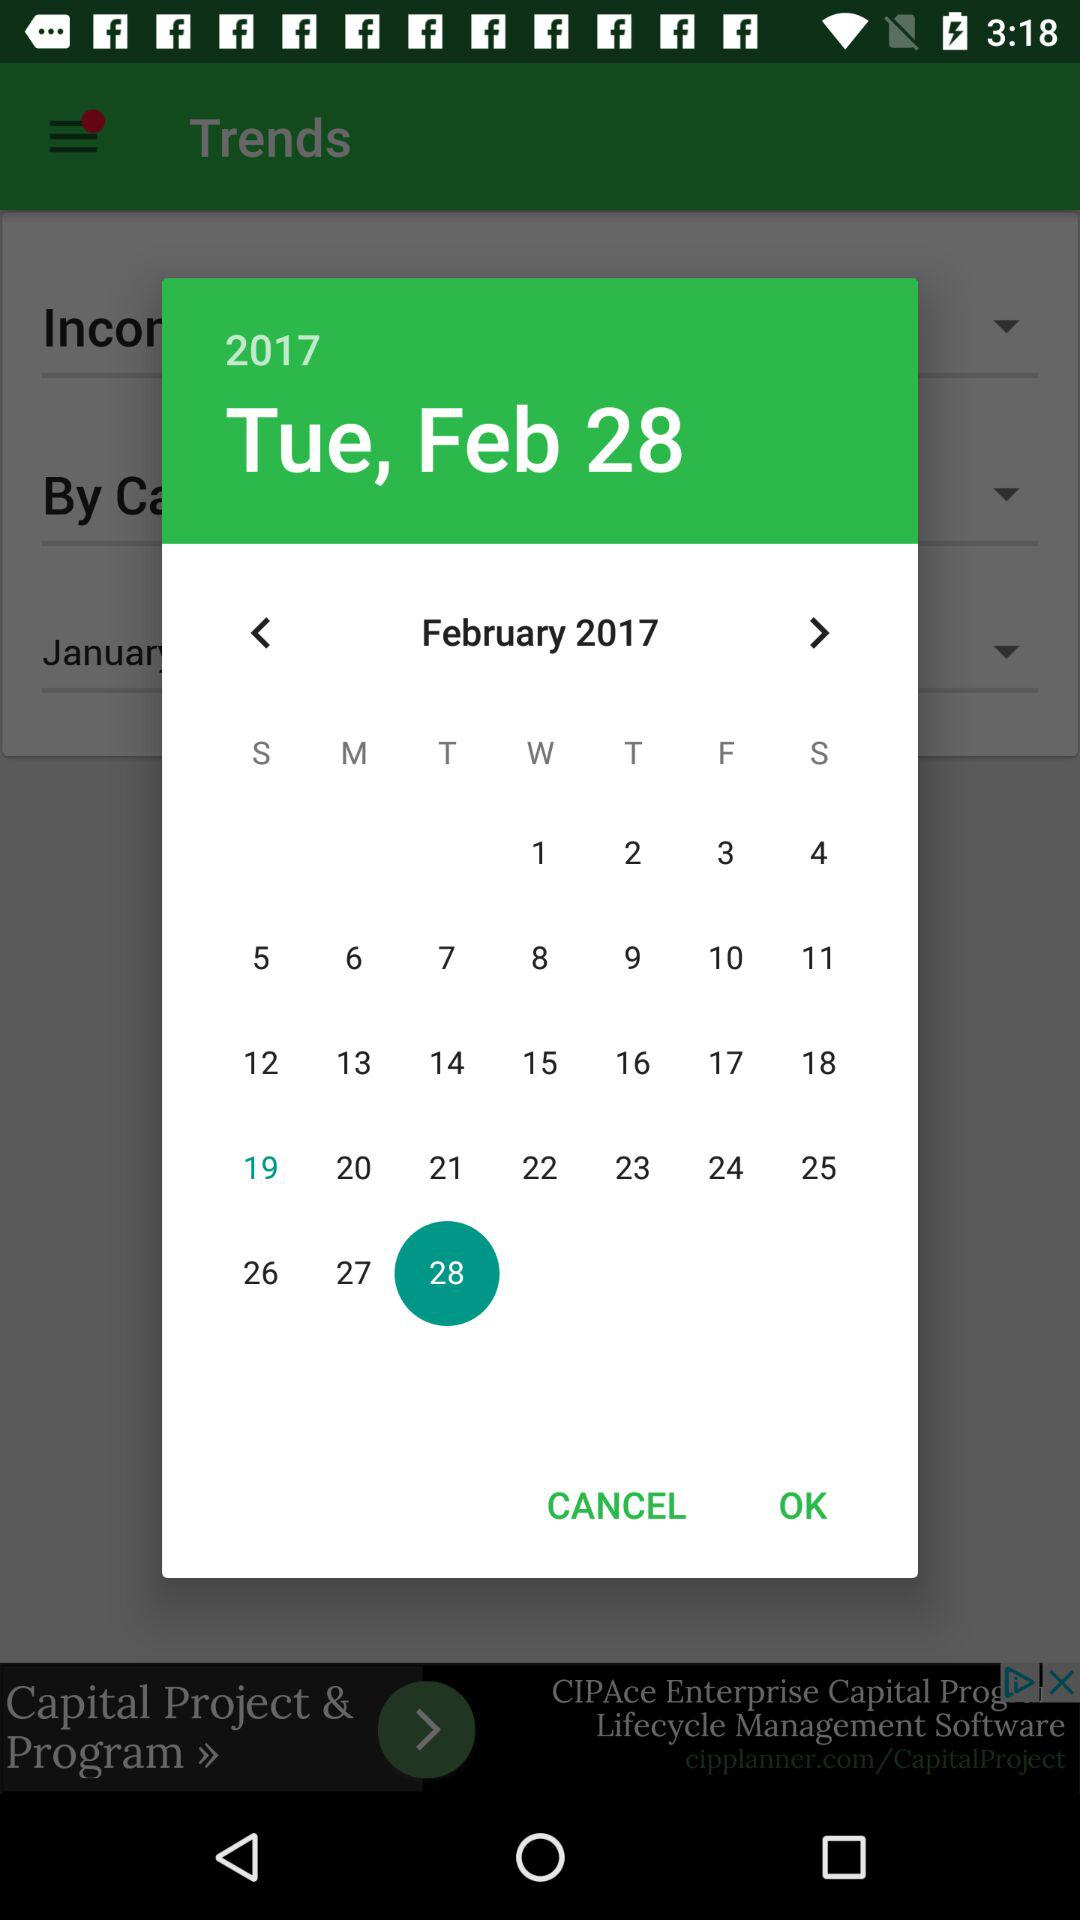Which date is selected? The selected date is Tuesday, February 28, 2017. 